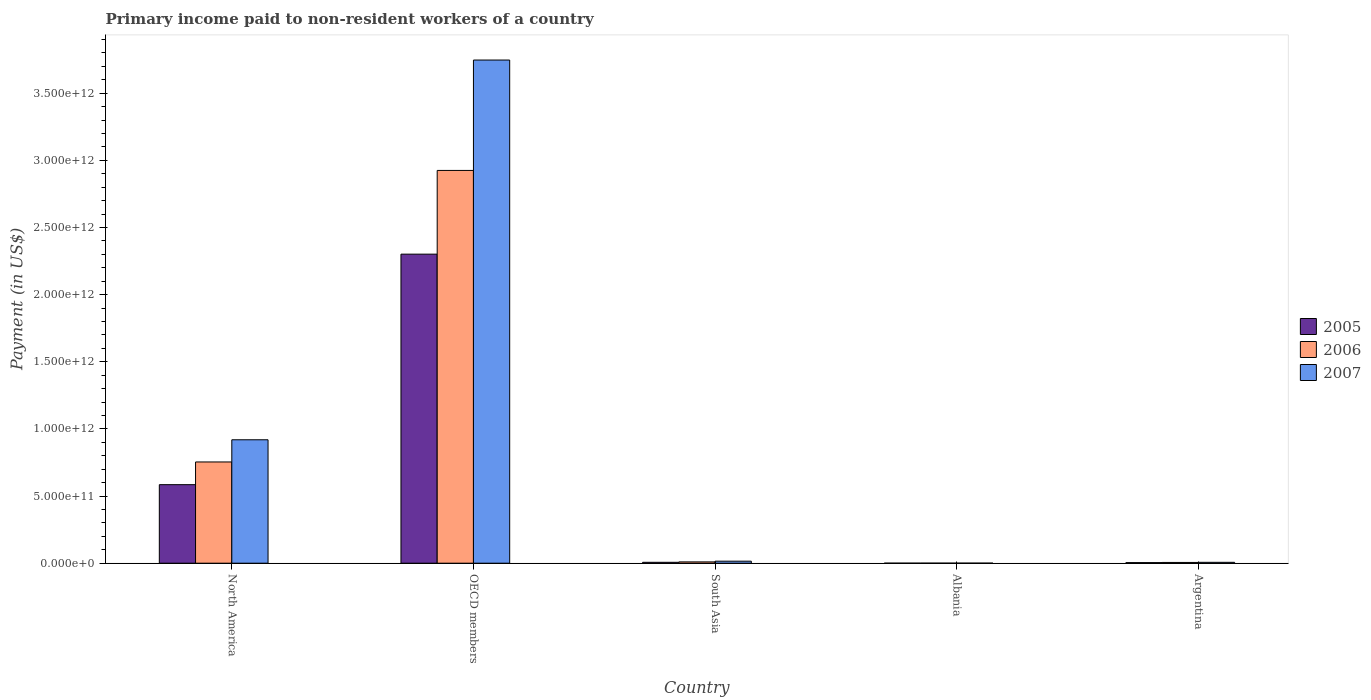How many different coloured bars are there?
Offer a very short reply. 3. How many groups of bars are there?
Make the answer very short. 5. Are the number of bars per tick equal to the number of legend labels?
Your answer should be compact. Yes. How many bars are there on the 4th tick from the right?
Your response must be concise. 3. What is the label of the 2nd group of bars from the left?
Your answer should be compact. OECD members. What is the amount paid to workers in 2006 in South Asia?
Your answer should be very brief. 9.75e+09. Across all countries, what is the maximum amount paid to workers in 2006?
Your answer should be very brief. 2.92e+12. Across all countries, what is the minimum amount paid to workers in 2006?
Provide a short and direct response. 3.32e+08. In which country was the amount paid to workers in 2007 maximum?
Your answer should be very brief. OECD members. In which country was the amount paid to workers in 2006 minimum?
Your answer should be very brief. Albania. What is the total amount paid to workers in 2005 in the graph?
Give a very brief answer. 2.90e+12. What is the difference between the amount paid to workers in 2006 in OECD members and that in South Asia?
Provide a succinct answer. 2.91e+12. What is the difference between the amount paid to workers in 2006 in Argentina and the amount paid to workers in 2005 in OECD members?
Your answer should be compact. -2.30e+12. What is the average amount paid to workers in 2005 per country?
Offer a very short reply. 5.79e+11. What is the difference between the amount paid to workers of/in 2006 and amount paid to workers of/in 2005 in South Asia?
Your response must be concise. 3.09e+09. In how many countries, is the amount paid to workers in 2007 greater than 3700000000000 US$?
Your response must be concise. 1. What is the ratio of the amount paid to workers in 2006 in OECD members to that in South Asia?
Keep it short and to the point. 299.92. Is the amount paid to workers in 2006 in North America less than that in South Asia?
Provide a short and direct response. No. Is the difference between the amount paid to workers in 2006 in Albania and Argentina greater than the difference between the amount paid to workers in 2005 in Albania and Argentina?
Keep it short and to the point. No. What is the difference between the highest and the second highest amount paid to workers in 2006?
Your answer should be very brief. -2.17e+12. What is the difference between the highest and the lowest amount paid to workers in 2005?
Offer a terse response. 2.30e+12. In how many countries, is the amount paid to workers in 2005 greater than the average amount paid to workers in 2005 taken over all countries?
Give a very brief answer. 2. Is the sum of the amount paid to workers in 2007 in Argentina and South Asia greater than the maximum amount paid to workers in 2005 across all countries?
Provide a succinct answer. No. What does the 3rd bar from the left in South Asia represents?
Your response must be concise. 2007. What does the 3rd bar from the right in South Asia represents?
Ensure brevity in your answer.  2005. Is it the case that in every country, the sum of the amount paid to workers in 2005 and amount paid to workers in 2006 is greater than the amount paid to workers in 2007?
Give a very brief answer. Yes. How many bars are there?
Offer a terse response. 15. Are all the bars in the graph horizontal?
Ensure brevity in your answer.  No. What is the difference between two consecutive major ticks on the Y-axis?
Offer a terse response. 5.00e+11. Where does the legend appear in the graph?
Offer a very short reply. Center right. How many legend labels are there?
Your answer should be very brief. 3. What is the title of the graph?
Your response must be concise. Primary income paid to non-resident workers of a country. Does "1973" appear as one of the legend labels in the graph?
Your response must be concise. No. What is the label or title of the X-axis?
Your answer should be compact. Country. What is the label or title of the Y-axis?
Make the answer very short. Payment (in US$). What is the Payment (in US$) of 2005 in North America?
Provide a succinct answer. 5.85e+11. What is the Payment (in US$) of 2006 in North America?
Your response must be concise. 7.54e+11. What is the Payment (in US$) of 2007 in North America?
Your answer should be compact. 9.19e+11. What is the Payment (in US$) in 2005 in OECD members?
Your response must be concise. 2.30e+12. What is the Payment (in US$) in 2006 in OECD members?
Ensure brevity in your answer.  2.92e+12. What is the Payment (in US$) of 2007 in OECD members?
Your answer should be very brief. 3.75e+12. What is the Payment (in US$) in 2005 in South Asia?
Offer a very short reply. 6.66e+09. What is the Payment (in US$) in 2006 in South Asia?
Make the answer very short. 9.75e+09. What is the Payment (in US$) in 2007 in South Asia?
Give a very brief answer. 1.50e+1. What is the Payment (in US$) of 2005 in Albania?
Make the answer very short. 2.27e+08. What is the Payment (in US$) in 2006 in Albania?
Offer a very short reply. 3.32e+08. What is the Payment (in US$) of 2007 in Albania?
Make the answer very short. 3.82e+08. What is the Payment (in US$) in 2005 in Argentina?
Offer a very short reply. 4.31e+09. What is the Payment (in US$) of 2006 in Argentina?
Provide a short and direct response. 5.69e+09. What is the Payment (in US$) of 2007 in Argentina?
Your response must be concise. 6.62e+09. Across all countries, what is the maximum Payment (in US$) of 2005?
Ensure brevity in your answer.  2.30e+12. Across all countries, what is the maximum Payment (in US$) of 2006?
Your answer should be compact. 2.92e+12. Across all countries, what is the maximum Payment (in US$) of 2007?
Make the answer very short. 3.75e+12. Across all countries, what is the minimum Payment (in US$) of 2005?
Give a very brief answer. 2.27e+08. Across all countries, what is the minimum Payment (in US$) in 2006?
Your response must be concise. 3.32e+08. Across all countries, what is the minimum Payment (in US$) in 2007?
Offer a terse response. 3.82e+08. What is the total Payment (in US$) of 2005 in the graph?
Offer a terse response. 2.90e+12. What is the total Payment (in US$) in 2006 in the graph?
Your response must be concise. 3.69e+12. What is the total Payment (in US$) of 2007 in the graph?
Your answer should be very brief. 4.69e+12. What is the difference between the Payment (in US$) in 2005 in North America and that in OECD members?
Give a very brief answer. -1.72e+12. What is the difference between the Payment (in US$) of 2006 in North America and that in OECD members?
Offer a very short reply. -2.17e+12. What is the difference between the Payment (in US$) in 2007 in North America and that in OECD members?
Your answer should be very brief. -2.83e+12. What is the difference between the Payment (in US$) in 2005 in North America and that in South Asia?
Make the answer very short. 5.78e+11. What is the difference between the Payment (in US$) of 2006 in North America and that in South Asia?
Offer a very short reply. 7.44e+11. What is the difference between the Payment (in US$) of 2007 in North America and that in South Asia?
Provide a short and direct response. 9.04e+11. What is the difference between the Payment (in US$) in 2005 in North America and that in Albania?
Make the answer very short. 5.85e+11. What is the difference between the Payment (in US$) of 2006 in North America and that in Albania?
Offer a terse response. 7.54e+11. What is the difference between the Payment (in US$) in 2007 in North America and that in Albania?
Provide a succinct answer. 9.19e+11. What is the difference between the Payment (in US$) of 2005 in North America and that in Argentina?
Your answer should be very brief. 5.80e+11. What is the difference between the Payment (in US$) in 2006 in North America and that in Argentina?
Offer a very short reply. 7.48e+11. What is the difference between the Payment (in US$) in 2007 in North America and that in Argentina?
Offer a very short reply. 9.12e+11. What is the difference between the Payment (in US$) of 2005 in OECD members and that in South Asia?
Your answer should be compact. 2.29e+12. What is the difference between the Payment (in US$) in 2006 in OECD members and that in South Asia?
Make the answer very short. 2.91e+12. What is the difference between the Payment (in US$) of 2007 in OECD members and that in South Asia?
Ensure brevity in your answer.  3.73e+12. What is the difference between the Payment (in US$) in 2005 in OECD members and that in Albania?
Your answer should be compact. 2.30e+12. What is the difference between the Payment (in US$) of 2006 in OECD members and that in Albania?
Ensure brevity in your answer.  2.92e+12. What is the difference between the Payment (in US$) of 2007 in OECD members and that in Albania?
Your response must be concise. 3.75e+12. What is the difference between the Payment (in US$) in 2005 in OECD members and that in Argentina?
Your response must be concise. 2.30e+12. What is the difference between the Payment (in US$) of 2006 in OECD members and that in Argentina?
Your answer should be compact. 2.92e+12. What is the difference between the Payment (in US$) of 2007 in OECD members and that in Argentina?
Give a very brief answer. 3.74e+12. What is the difference between the Payment (in US$) of 2005 in South Asia and that in Albania?
Your answer should be very brief. 6.44e+09. What is the difference between the Payment (in US$) of 2006 in South Asia and that in Albania?
Make the answer very short. 9.42e+09. What is the difference between the Payment (in US$) in 2007 in South Asia and that in Albania?
Offer a very short reply. 1.46e+1. What is the difference between the Payment (in US$) in 2005 in South Asia and that in Argentina?
Your answer should be very brief. 2.35e+09. What is the difference between the Payment (in US$) in 2006 in South Asia and that in Argentina?
Your response must be concise. 4.07e+09. What is the difference between the Payment (in US$) of 2007 in South Asia and that in Argentina?
Make the answer very short. 8.38e+09. What is the difference between the Payment (in US$) of 2005 in Albania and that in Argentina?
Make the answer very short. -4.09e+09. What is the difference between the Payment (in US$) of 2006 in Albania and that in Argentina?
Provide a succinct answer. -5.35e+09. What is the difference between the Payment (in US$) in 2007 in Albania and that in Argentina?
Give a very brief answer. -6.24e+09. What is the difference between the Payment (in US$) in 2005 in North America and the Payment (in US$) in 2006 in OECD members?
Give a very brief answer. -2.34e+12. What is the difference between the Payment (in US$) in 2005 in North America and the Payment (in US$) in 2007 in OECD members?
Offer a terse response. -3.16e+12. What is the difference between the Payment (in US$) of 2006 in North America and the Payment (in US$) of 2007 in OECD members?
Give a very brief answer. -2.99e+12. What is the difference between the Payment (in US$) of 2005 in North America and the Payment (in US$) of 2006 in South Asia?
Provide a succinct answer. 5.75e+11. What is the difference between the Payment (in US$) of 2005 in North America and the Payment (in US$) of 2007 in South Asia?
Keep it short and to the point. 5.70e+11. What is the difference between the Payment (in US$) in 2006 in North America and the Payment (in US$) in 2007 in South Asia?
Keep it short and to the point. 7.39e+11. What is the difference between the Payment (in US$) of 2005 in North America and the Payment (in US$) of 2006 in Albania?
Your answer should be very brief. 5.84e+11. What is the difference between the Payment (in US$) of 2005 in North America and the Payment (in US$) of 2007 in Albania?
Offer a very short reply. 5.84e+11. What is the difference between the Payment (in US$) in 2006 in North America and the Payment (in US$) in 2007 in Albania?
Make the answer very short. 7.53e+11. What is the difference between the Payment (in US$) in 2005 in North America and the Payment (in US$) in 2006 in Argentina?
Your answer should be compact. 5.79e+11. What is the difference between the Payment (in US$) in 2005 in North America and the Payment (in US$) in 2007 in Argentina?
Keep it short and to the point. 5.78e+11. What is the difference between the Payment (in US$) of 2006 in North America and the Payment (in US$) of 2007 in Argentina?
Offer a terse response. 7.47e+11. What is the difference between the Payment (in US$) in 2005 in OECD members and the Payment (in US$) in 2006 in South Asia?
Your response must be concise. 2.29e+12. What is the difference between the Payment (in US$) in 2005 in OECD members and the Payment (in US$) in 2007 in South Asia?
Give a very brief answer. 2.29e+12. What is the difference between the Payment (in US$) in 2006 in OECD members and the Payment (in US$) in 2007 in South Asia?
Offer a very short reply. 2.91e+12. What is the difference between the Payment (in US$) in 2005 in OECD members and the Payment (in US$) in 2006 in Albania?
Make the answer very short. 2.30e+12. What is the difference between the Payment (in US$) in 2005 in OECD members and the Payment (in US$) in 2007 in Albania?
Ensure brevity in your answer.  2.30e+12. What is the difference between the Payment (in US$) in 2006 in OECD members and the Payment (in US$) in 2007 in Albania?
Offer a terse response. 2.92e+12. What is the difference between the Payment (in US$) of 2005 in OECD members and the Payment (in US$) of 2006 in Argentina?
Provide a succinct answer. 2.30e+12. What is the difference between the Payment (in US$) in 2005 in OECD members and the Payment (in US$) in 2007 in Argentina?
Ensure brevity in your answer.  2.29e+12. What is the difference between the Payment (in US$) of 2006 in OECD members and the Payment (in US$) of 2007 in Argentina?
Make the answer very short. 2.92e+12. What is the difference between the Payment (in US$) of 2005 in South Asia and the Payment (in US$) of 2006 in Albania?
Make the answer very short. 6.33e+09. What is the difference between the Payment (in US$) of 2005 in South Asia and the Payment (in US$) of 2007 in Albania?
Offer a very short reply. 6.28e+09. What is the difference between the Payment (in US$) of 2006 in South Asia and the Payment (in US$) of 2007 in Albania?
Offer a terse response. 9.37e+09. What is the difference between the Payment (in US$) in 2005 in South Asia and the Payment (in US$) in 2006 in Argentina?
Ensure brevity in your answer.  9.79e+08. What is the difference between the Payment (in US$) of 2005 in South Asia and the Payment (in US$) of 2007 in Argentina?
Give a very brief answer. 4.01e+07. What is the difference between the Payment (in US$) in 2006 in South Asia and the Payment (in US$) in 2007 in Argentina?
Provide a short and direct response. 3.13e+09. What is the difference between the Payment (in US$) of 2005 in Albania and the Payment (in US$) of 2006 in Argentina?
Your answer should be very brief. -5.46e+09. What is the difference between the Payment (in US$) in 2005 in Albania and the Payment (in US$) in 2007 in Argentina?
Provide a short and direct response. -6.40e+09. What is the difference between the Payment (in US$) in 2006 in Albania and the Payment (in US$) in 2007 in Argentina?
Offer a terse response. -6.29e+09. What is the average Payment (in US$) in 2005 per country?
Give a very brief answer. 5.79e+11. What is the average Payment (in US$) in 2006 per country?
Ensure brevity in your answer.  7.39e+11. What is the average Payment (in US$) in 2007 per country?
Your response must be concise. 9.38e+11. What is the difference between the Payment (in US$) of 2005 and Payment (in US$) of 2006 in North America?
Your answer should be compact. -1.69e+11. What is the difference between the Payment (in US$) of 2005 and Payment (in US$) of 2007 in North America?
Provide a short and direct response. -3.34e+11. What is the difference between the Payment (in US$) in 2006 and Payment (in US$) in 2007 in North America?
Your answer should be compact. -1.65e+11. What is the difference between the Payment (in US$) in 2005 and Payment (in US$) in 2006 in OECD members?
Your response must be concise. -6.23e+11. What is the difference between the Payment (in US$) in 2005 and Payment (in US$) in 2007 in OECD members?
Keep it short and to the point. -1.45e+12. What is the difference between the Payment (in US$) in 2006 and Payment (in US$) in 2007 in OECD members?
Your answer should be compact. -8.22e+11. What is the difference between the Payment (in US$) of 2005 and Payment (in US$) of 2006 in South Asia?
Your answer should be very brief. -3.09e+09. What is the difference between the Payment (in US$) in 2005 and Payment (in US$) in 2007 in South Asia?
Make the answer very short. -8.34e+09. What is the difference between the Payment (in US$) of 2006 and Payment (in US$) of 2007 in South Asia?
Give a very brief answer. -5.25e+09. What is the difference between the Payment (in US$) of 2005 and Payment (in US$) of 2006 in Albania?
Give a very brief answer. -1.05e+08. What is the difference between the Payment (in US$) in 2005 and Payment (in US$) in 2007 in Albania?
Provide a succinct answer. -1.56e+08. What is the difference between the Payment (in US$) in 2006 and Payment (in US$) in 2007 in Albania?
Ensure brevity in your answer.  -5.03e+07. What is the difference between the Payment (in US$) of 2005 and Payment (in US$) of 2006 in Argentina?
Your response must be concise. -1.37e+09. What is the difference between the Payment (in US$) of 2005 and Payment (in US$) of 2007 in Argentina?
Give a very brief answer. -2.31e+09. What is the difference between the Payment (in US$) in 2006 and Payment (in US$) in 2007 in Argentina?
Offer a terse response. -9.39e+08. What is the ratio of the Payment (in US$) in 2005 in North America to that in OECD members?
Offer a very short reply. 0.25. What is the ratio of the Payment (in US$) of 2006 in North America to that in OECD members?
Give a very brief answer. 0.26. What is the ratio of the Payment (in US$) of 2007 in North America to that in OECD members?
Offer a terse response. 0.25. What is the ratio of the Payment (in US$) of 2005 in North America to that in South Asia?
Offer a terse response. 87.74. What is the ratio of the Payment (in US$) of 2006 in North America to that in South Asia?
Keep it short and to the point. 77.31. What is the ratio of the Payment (in US$) in 2007 in North America to that in South Asia?
Your answer should be compact. 61.25. What is the ratio of the Payment (in US$) of 2005 in North America to that in Albania?
Offer a very short reply. 2579.86. What is the ratio of the Payment (in US$) of 2006 in North America to that in Albania?
Your answer should be very brief. 2269.85. What is the ratio of the Payment (in US$) of 2007 in North America to that in Albania?
Give a very brief answer. 2403.09. What is the ratio of the Payment (in US$) in 2005 in North America to that in Argentina?
Your response must be concise. 135.62. What is the ratio of the Payment (in US$) of 2006 in North America to that in Argentina?
Keep it short and to the point. 132.6. What is the ratio of the Payment (in US$) of 2007 in North America to that in Argentina?
Your answer should be very brief. 138.73. What is the ratio of the Payment (in US$) in 2005 in OECD members to that in South Asia?
Provide a short and direct response. 345.3. What is the ratio of the Payment (in US$) in 2006 in OECD members to that in South Asia?
Make the answer very short. 299.92. What is the ratio of the Payment (in US$) in 2007 in OECD members to that in South Asia?
Your response must be concise. 249.69. What is the ratio of the Payment (in US$) in 2005 in OECD members to that in Albania?
Make the answer very short. 1.02e+04. What is the ratio of the Payment (in US$) in 2006 in OECD members to that in Albania?
Your answer should be compact. 8806.07. What is the ratio of the Payment (in US$) of 2007 in OECD members to that in Albania?
Keep it short and to the point. 9796.97. What is the ratio of the Payment (in US$) in 2005 in OECD members to that in Argentina?
Provide a short and direct response. 533.72. What is the ratio of the Payment (in US$) in 2006 in OECD members to that in Argentina?
Your answer should be very brief. 514.43. What is the ratio of the Payment (in US$) of 2007 in OECD members to that in Argentina?
Ensure brevity in your answer.  565.57. What is the ratio of the Payment (in US$) of 2005 in South Asia to that in Albania?
Give a very brief answer. 29.4. What is the ratio of the Payment (in US$) in 2006 in South Asia to that in Albania?
Provide a short and direct response. 29.36. What is the ratio of the Payment (in US$) in 2007 in South Asia to that in Albania?
Offer a terse response. 39.24. What is the ratio of the Payment (in US$) of 2005 in South Asia to that in Argentina?
Your response must be concise. 1.55. What is the ratio of the Payment (in US$) of 2006 in South Asia to that in Argentina?
Offer a very short reply. 1.72. What is the ratio of the Payment (in US$) in 2007 in South Asia to that in Argentina?
Your answer should be compact. 2.27. What is the ratio of the Payment (in US$) in 2005 in Albania to that in Argentina?
Keep it short and to the point. 0.05. What is the ratio of the Payment (in US$) of 2006 in Albania to that in Argentina?
Give a very brief answer. 0.06. What is the ratio of the Payment (in US$) in 2007 in Albania to that in Argentina?
Keep it short and to the point. 0.06. What is the difference between the highest and the second highest Payment (in US$) of 2005?
Your response must be concise. 1.72e+12. What is the difference between the highest and the second highest Payment (in US$) of 2006?
Offer a very short reply. 2.17e+12. What is the difference between the highest and the second highest Payment (in US$) of 2007?
Provide a succinct answer. 2.83e+12. What is the difference between the highest and the lowest Payment (in US$) of 2005?
Provide a short and direct response. 2.30e+12. What is the difference between the highest and the lowest Payment (in US$) of 2006?
Your answer should be very brief. 2.92e+12. What is the difference between the highest and the lowest Payment (in US$) of 2007?
Provide a short and direct response. 3.75e+12. 